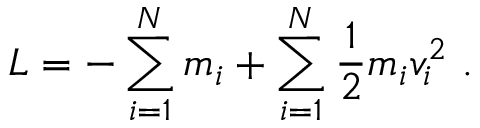<formula> <loc_0><loc_0><loc_500><loc_500>{ L = - \sum _ { i = 1 } ^ { N } m _ { i } + \sum _ { i = 1 } ^ { N } { \frac { 1 } { 2 } } m _ { i } v _ { i } ^ { 2 } \ . }</formula> 